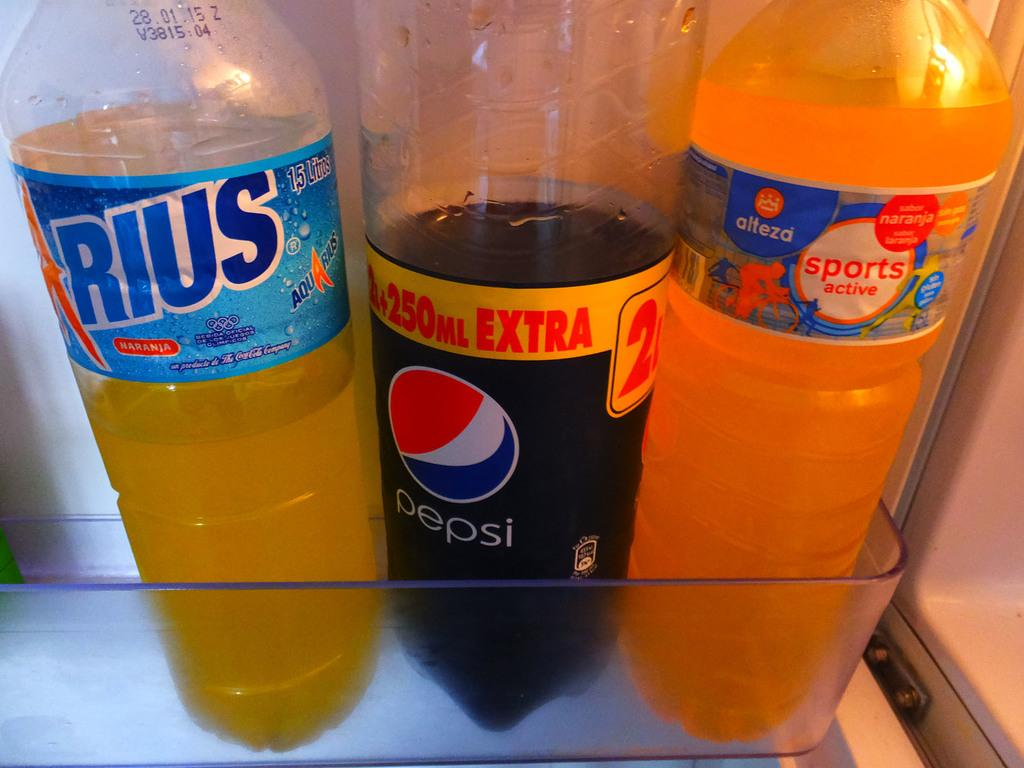Provide a one-sentence caption for the provided image. Three bottles of soda on a clear palstic shelf with a Pepsi in the middle. 